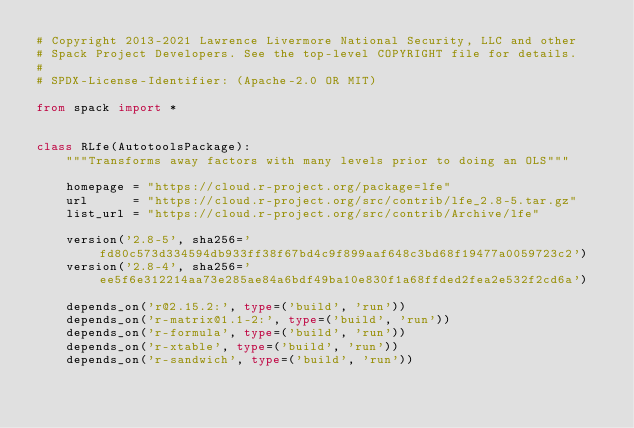Convert code to text. <code><loc_0><loc_0><loc_500><loc_500><_Python_># Copyright 2013-2021 Lawrence Livermore National Security, LLC and other
# Spack Project Developers. See the top-level COPYRIGHT file for details.
#
# SPDX-License-Identifier: (Apache-2.0 OR MIT)

from spack import *


class RLfe(AutotoolsPackage):
    """Transforms away factors with many levels prior to doing an OLS"""

    homepage = "https://cloud.r-project.org/package=lfe"
    url      = "https://cloud.r-project.org/src/contrib/lfe_2.8-5.tar.gz"
    list_url = "https://cloud.r-project.org/src/contrib/Archive/lfe"

    version('2.8-5', sha256='fd80c573d334594db933ff38f67bd4c9f899aaf648c3bd68f19477a0059723c2')
    version('2.8-4', sha256='ee5f6e312214aa73e285ae84a6bdf49ba10e830f1a68ffded2fea2e532f2cd6a')

    depends_on('r@2.15.2:', type=('build', 'run'))
    depends_on('r-matrix@1.1-2:', type=('build', 'run'))
    depends_on('r-formula', type=('build', 'run'))
    depends_on('r-xtable', type=('build', 'run'))
    depends_on('r-sandwich', type=('build', 'run'))
</code> 